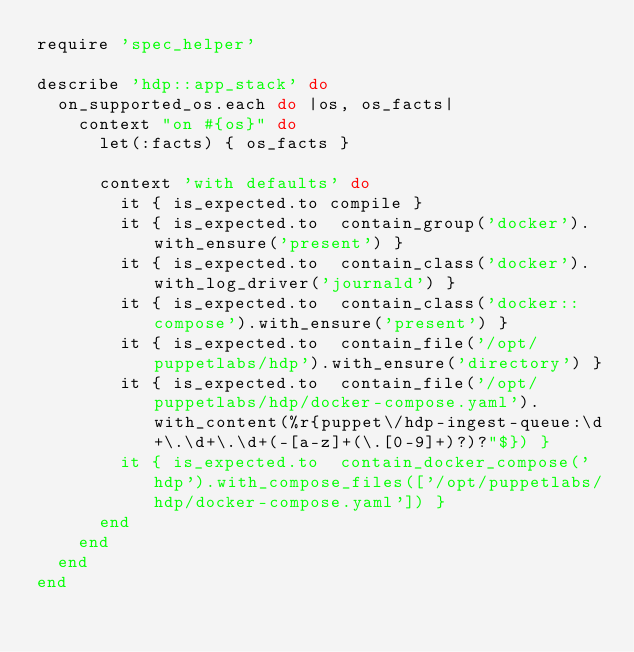Convert code to text. <code><loc_0><loc_0><loc_500><loc_500><_Ruby_>require 'spec_helper'

describe 'hdp::app_stack' do
  on_supported_os.each do |os, os_facts|
    context "on #{os}" do
      let(:facts) { os_facts }

      context 'with defaults' do
        it { is_expected.to compile }
        it { is_expected.to  contain_group('docker').with_ensure('present') }
        it { is_expected.to  contain_class('docker').with_log_driver('journald') }
        it { is_expected.to  contain_class('docker::compose').with_ensure('present') }
        it { is_expected.to  contain_file('/opt/puppetlabs/hdp').with_ensure('directory') }
        it { is_expected.to  contain_file('/opt/puppetlabs/hdp/docker-compose.yaml').with_content(%r{puppet\/hdp-ingest-queue:\d+\.\d+\.\d+(-[a-z]+(\.[0-9]+)?)?"$}) }
        it { is_expected.to  contain_docker_compose('hdp').with_compose_files(['/opt/puppetlabs/hdp/docker-compose.yaml']) }
      end
    end
  end
end
</code> 